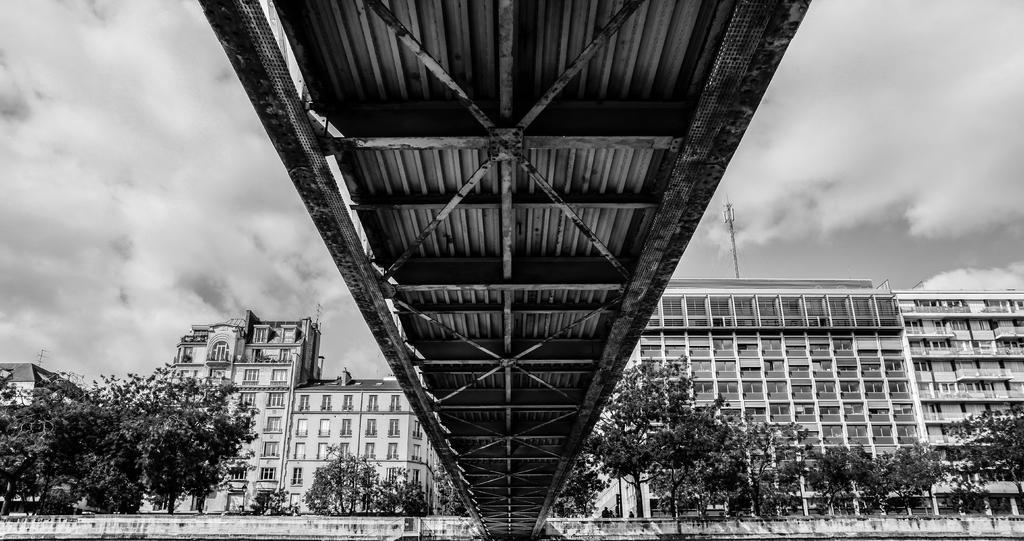In one or two sentences, can you explain what this image depicts? In the image we can see there are many buildings and these are the windows of the buildings. There are many trees and a cloudy sky. This is a pole and this is a bridge. 